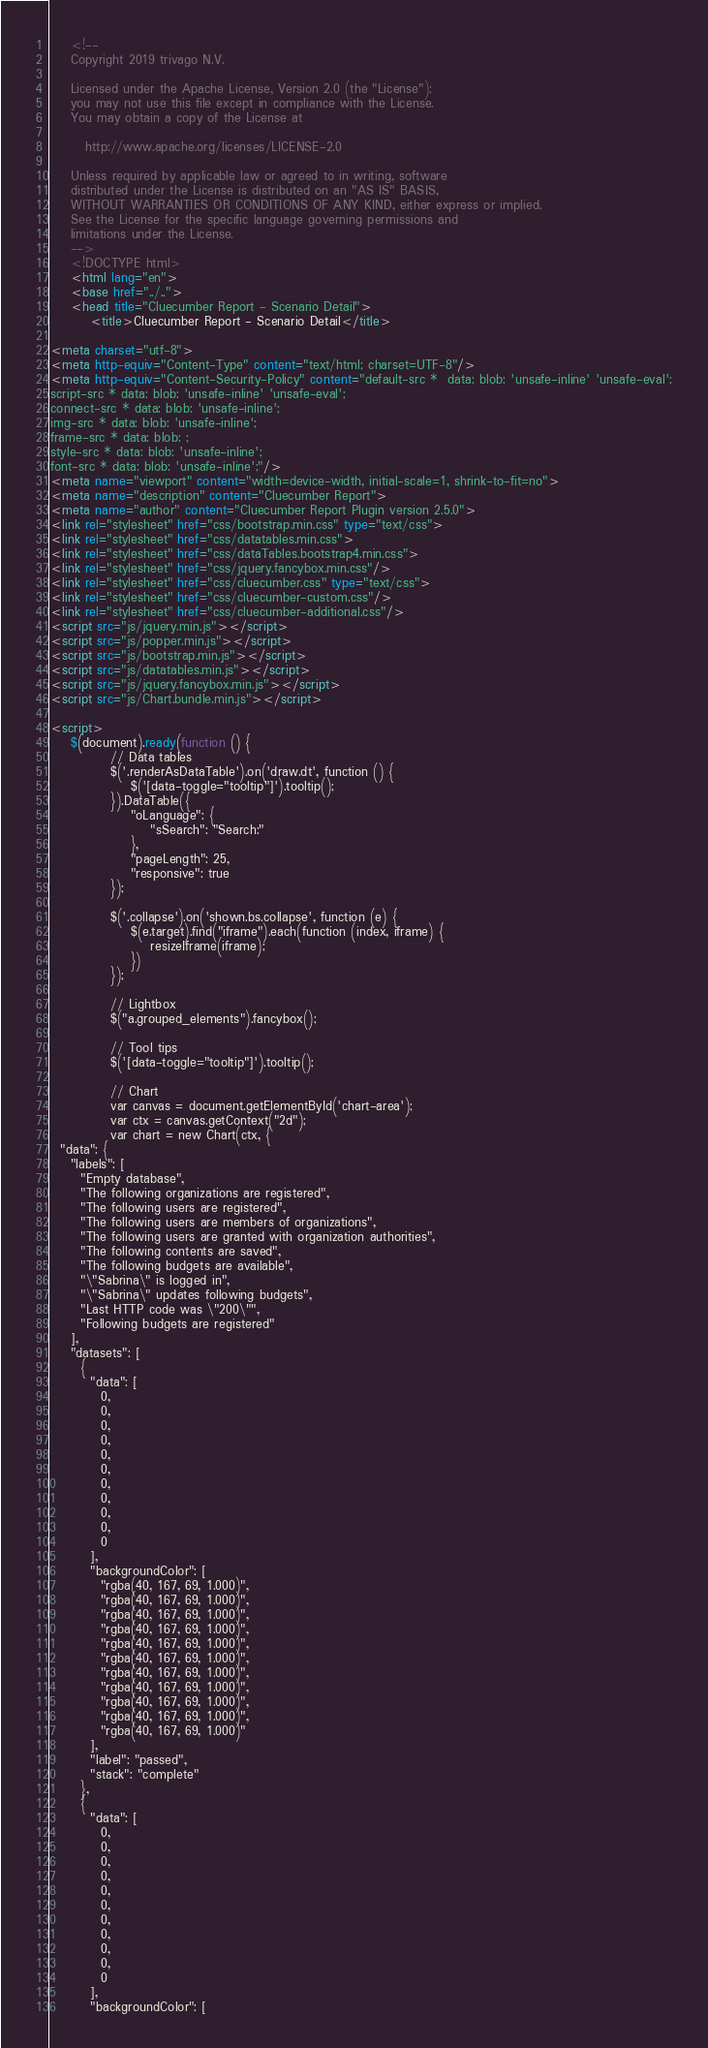<code> <loc_0><loc_0><loc_500><loc_500><_HTML_>
    <!--
    Copyright 2019 trivago N.V.

    Licensed under the Apache License, Version 2.0 (the "License");
    you may not use this file except in compliance with the License.
    You may obtain a copy of the License at

       http://www.apache.org/licenses/LICENSE-2.0

    Unless required by applicable law or agreed to in writing, software
    distributed under the License is distributed on an "AS IS" BASIS,
    WITHOUT WARRANTIES OR CONDITIONS OF ANY KIND, either express or implied.
    See the License for the specific language governing permissions and
    limitations under the License.
    -->
    <!DOCTYPE html>
    <html lang="en">
    <base href="../..">
    <head title="Cluecumber Report - Scenario Detail">
        <title>Cluecumber Report - Scenario Detail</title>

<meta charset="utf-8">
<meta http-equiv="Content-Type" content="text/html; charset=UTF-8"/>
<meta http-equiv="Content-Security-Policy" content="default-src *  data: blob: 'unsafe-inline' 'unsafe-eval';
script-src * data: blob: 'unsafe-inline' 'unsafe-eval';
connect-src * data: blob: 'unsafe-inline';
img-src * data: blob: 'unsafe-inline';
frame-src * data: blob: ;
style-src * data: blob: 'unsafe-inline';
font-src * data: blob: 'unsafe-inline';"/>
<meta name="viewport" content="width=device-width, initial-scale=1, shrink-to-fit=no">
<meta name="description" content="Cluecumber Report">
<meta name="author" content="Cluecumber Report Plugin version 2.5.0">
<link rel="stylesheet" href="css/bootstrap.min.css" type="text/css">
<link rel="stylesheet" href="css/datatables.min.css">
<link rel="stylesheet" href="css/dataTables.bootstrap4.min.css">
<link rel="stylesheet" href="css/jquery.fancybox.min.css"/>
<link rel="stylesheet" href="css/cluecumber.css" type="text/css">
<link rel="stylesheet" href="css/cluecumber-custom.css"/>
<link rel="stylesheet" href="css/cluecumber-additional.css"/>
<script src="js/jquery.min.js"></script>
<script src="js/popper.min.js"></script>
<script src="js/bootstrap.min.js"></script>
<script src="js/datatables.min.js"></script>
<script src="js/jquery.fancybox.min.js"></script>
<script src="js/Chart.bundle.min.js"></script>

<script>
    $(document).ready(function () {
            // Data tables
            $('.renderAsDataTable').on('draw.dt', function () {
                $('[data-toggle="tooltip"]').tooltip();
            }).DataTable({
                "oLanguage": {
                    "sSearch": "Search:"
                },
                "pageLength": 25,
                "responsive": true
            });

            $('.collapse').on('shown.bs.collapse', function (e) {
                $(e.target).find("iframe").each(function (index, iframe) {
                    resizeIframe(iframe);
                })
            });

            // Lightbox
            $("a.grouped_elements").fancybox();

            // Tool tips
            $('[data-toggle="tooltip"]').tooltip();

            // Chart
            var canvas = document.getElementById('chart-area');
            var ctx = canvas.getContext("2d");
            var chart = new Chart(ctx, {
  "data": {
    "labels": [
      "Empty database",
      "The following organizations are registered",
      "The following users are registered",
      "The following users are members of organizations",
      "The following users are granted with organization authorities",
      "The following contents are saved",
      "The following budgets are available",
      "\"Sabrina\" is logged in",
      "\"Sabrina\" updates following budgets",
      "Last HTTP code was \"200\"",
      "Following budgets are registered"
    ],
    "datasets": [
      {
        "data": [
          0,
          0,
          0,
          0,
          0,
          0,
          0,
          0,
          0,
          0,
          0
        ],
        "backgroundColor": [
          "rgba(40, 167, 69, 1.000)",
          "rgba(40, 167, 69, 1.000)",
          "rgba(40, 167, 69, 1.000)",
          "rgba(40, 167, 69, 1.000)",
          "rgba(40, 167, 69, 1.000)",
          "rgba(40, 167, 69, 1.000)",
          "rgba(40, 167, 69, 1.000)",
          "rgba(40, 167, 69, 1.000)",
          "rgba(40, 167, 69, 1.000)",
          "rgba(40, 167, 69, 1.000)",
          "rgba(40, 167, 69, 1.000)"
        ],
        "label": "passed",
        "stack": "complete"
      },
      {
        "data": [
          0,
          0,
          0,
          0,
          0,
          0,
          0,
          0,
          0,
          0,
          0
        ],
        "backgroundColor": [</code> 